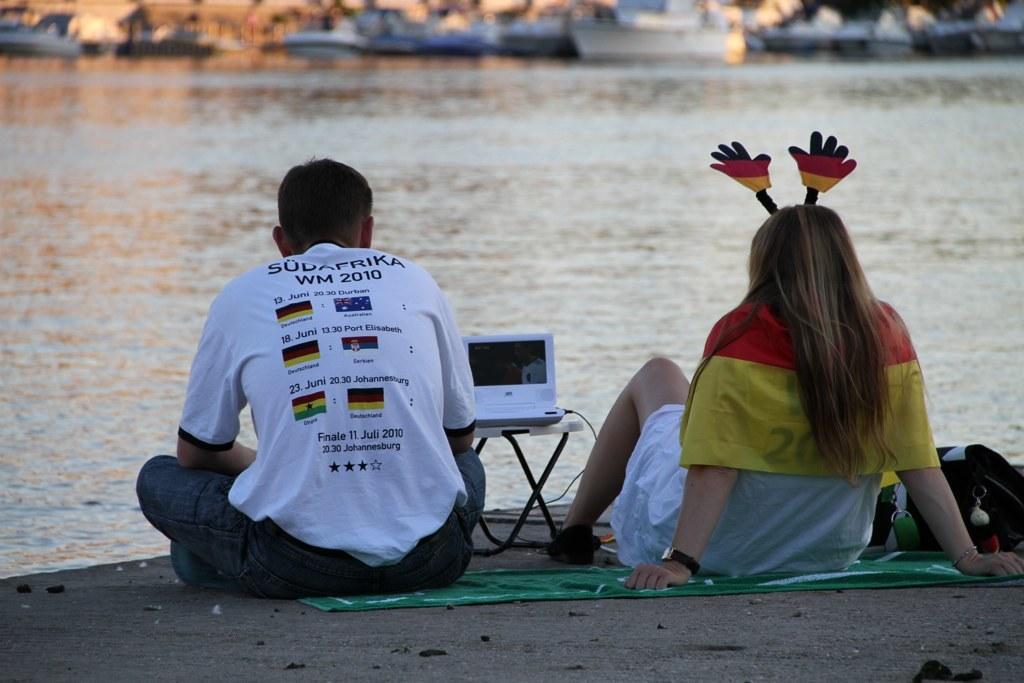Describe this image in one or two sentences. In this image we can see a man and a woman are sitting on a cloth on the sand at the water and we can see a laptop on a stand and on the right side there is a bag. In the background the image is not clear but we can see boats on the water. 